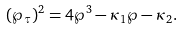Convert formula to latex. <formula><loc_0><loc_0><loc_500><loc_500>( \wp _ { \tau } ) ^ { 2 } = 4 \wp ^ { 3 } - \kappa _ { 1 } \wp - \kappa _ { 2 } .</formula> 